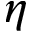<formula> <loc_0><loc_0><loc_500><loc_500>\eta</formula> 